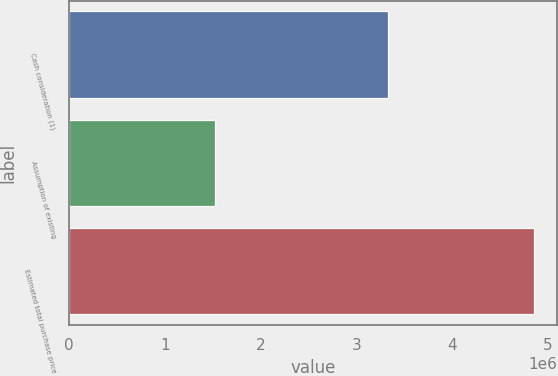Convert chart to OTSL. <chart><loc_0><loc_0><loc_500><loc_500><bar_chart><fcel>Cash consideration (1)<fcel>Assumption of existing<fcel>Estimated total purchase price<nl><fcel>3.33046e+06<fcel>1.52762e+06<fcel>4.85808e+06<nl></chart> 